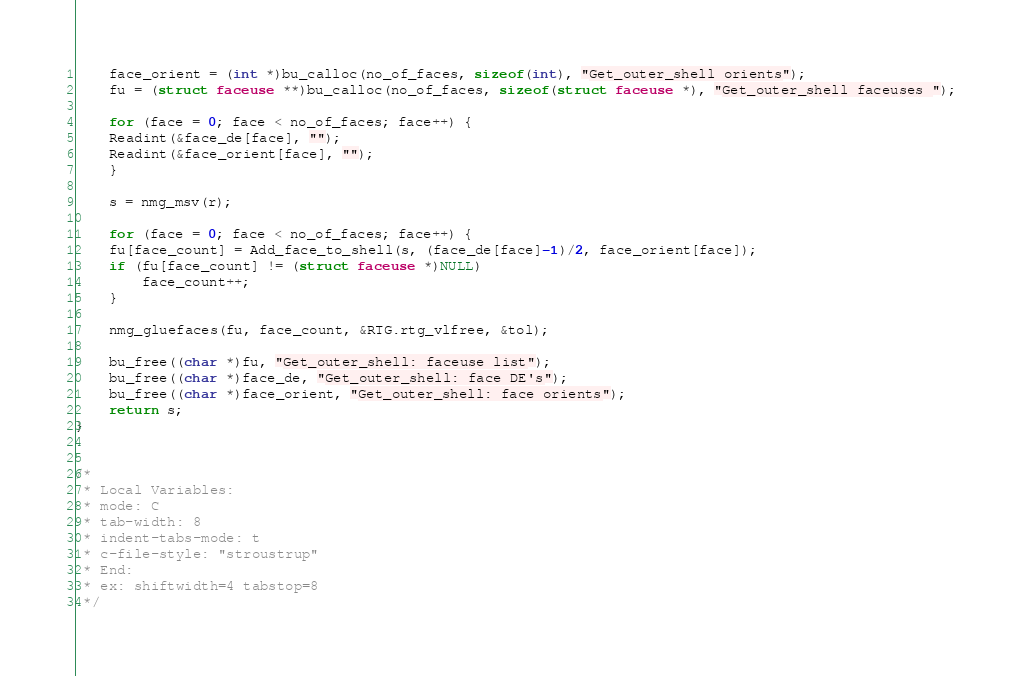<code> <loc_0><loc_0><loc_500><loc_500><_C_>    face_orient = (int *)bu_calloc(no_of_faces, sizeof(int), "Get_outer_shell orients");
    fu = (struct faceuse **)bu_calloc(no_of_faces, sizeof(struct faceuse *), "Get_outer_shell faceuses ");

    for (face = 0; face < no_of_faces; face++) {
	Readint(&face_de[face], "");
	Readint(&face_orient[face], "");
    }

    s = nmg_msv(r);

    for (face = 0; face < no_of_faces; face++) {
	fu[face_count] = Add_face_to_shell(s, (face_de[face]-1)/2, face_orient[face]);
	if (fu[face_count] != (struct faceuse *)NULL)
	    face_count++;
    }

    nmg_gluefaces(fu, face_count, &RTG.rtg_vlfree, &tol);

    bu_free((char *)fu, "Get_outer_shell: faceuse list");
    bu_free((char *)face_de, "Get_outer_shell: face DE's");
    bu_free((char *)face_orient, "Get_outer_shell: face orients");
    return s;
}


/*
 * Local Variables:
 * mode: C
 * tab-width: 8
 * indent-tabs-mode: t
 * c-file-style: "stroustrup"
 * End:
 * ex: shiftwidth=4 tabstop=8
 */
</code> 